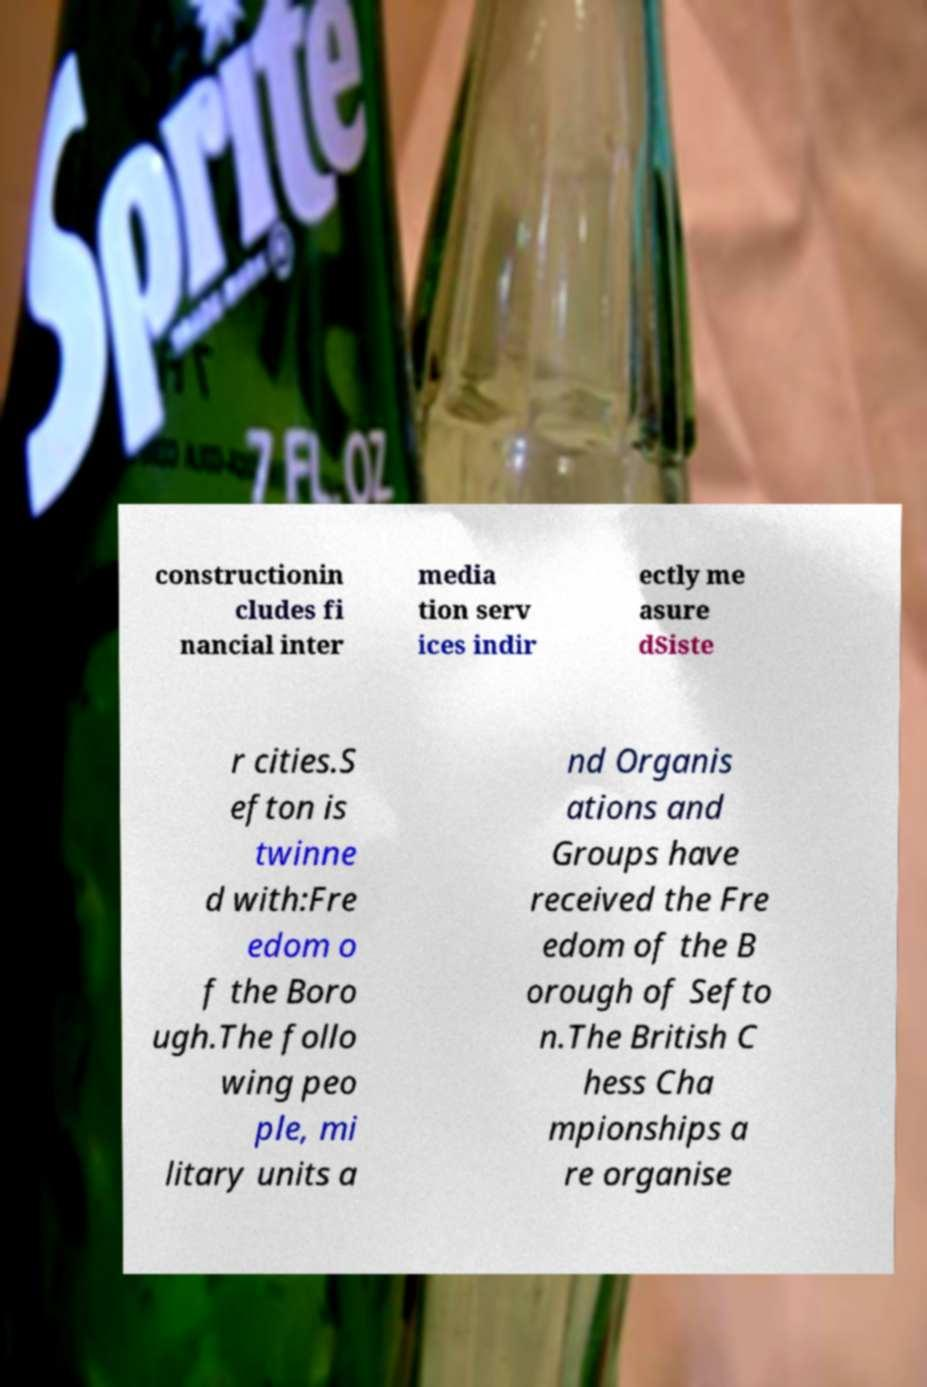Please identify and transcribe the text found in this image. constructionin cludes fi nancial inter media tion serv ices indir ectly me asure dSiste r cities.S efton is twinne d with:Fre edom o f the Boro ugh.The follo wing peo ple, mi litary units a nd Organis ations and Groups have received the Fre edom of the B orough of Sefto n.The British C hess Cha mpionships a re organise 